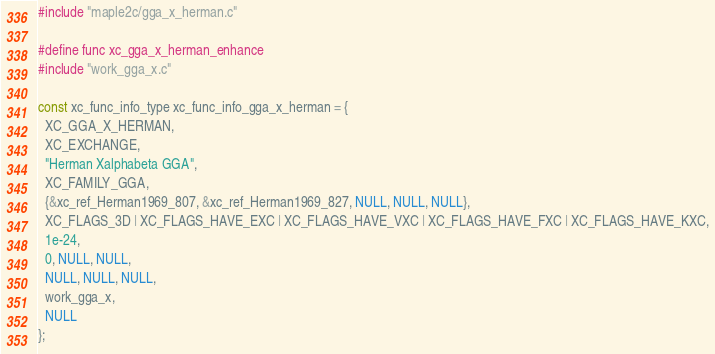<code> <loc_0><loc_0><loc_500><loc_500><_C_>#include "maple2c/gga_x_herman.c"

#define func xc_gga_x_herman_enhance
#include "work_gga_x.c"

const xc_func_info_type xc_func_info_gga_x_herman = {
  XC_GGA_X_HERMAN,
  XC_EXCHANGE,
  "Herman Xalphabeta GGA",
  XC_FAMILY_GGA,
  {&xc_ref_Herman1969_807, &xc_ref_Herman1969_827, NULL, NULL, NULL},
  XC_FLAGS_3D | XC_FLAGS_HAVE_EXC | XC_FLAGS_HAVE_VXC | XC_FLAGS_HAVE_FXC | XC_FLAGS_HAVE_KXC,
  1e-24,
  0, NULL, NULL,
  NULL, NULL, NULL,
  work_gga_x,
  NULL
};
</code> 